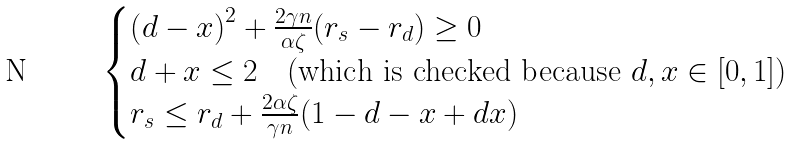Convert formula to latex. <formula><loc_0><loc_0><loc_500><loc_500>\begin{cases} \left ( d - x \right ) ^ { 2 } + \frac { 2 \gamma n } { \alpha \zeta } ( r _ { s } - r _ { d } ) \geq 0 \\ d + x \leq 2 \quad ( \text {which is checked because } d , x \in [ 0 , 1 ] ) \\ r _ { s } \leq r _ { d } + \frac { 2 \alpha \zeta } { \gamma n } ( 1 - d - x + d x ) \end{cases}</formula> 